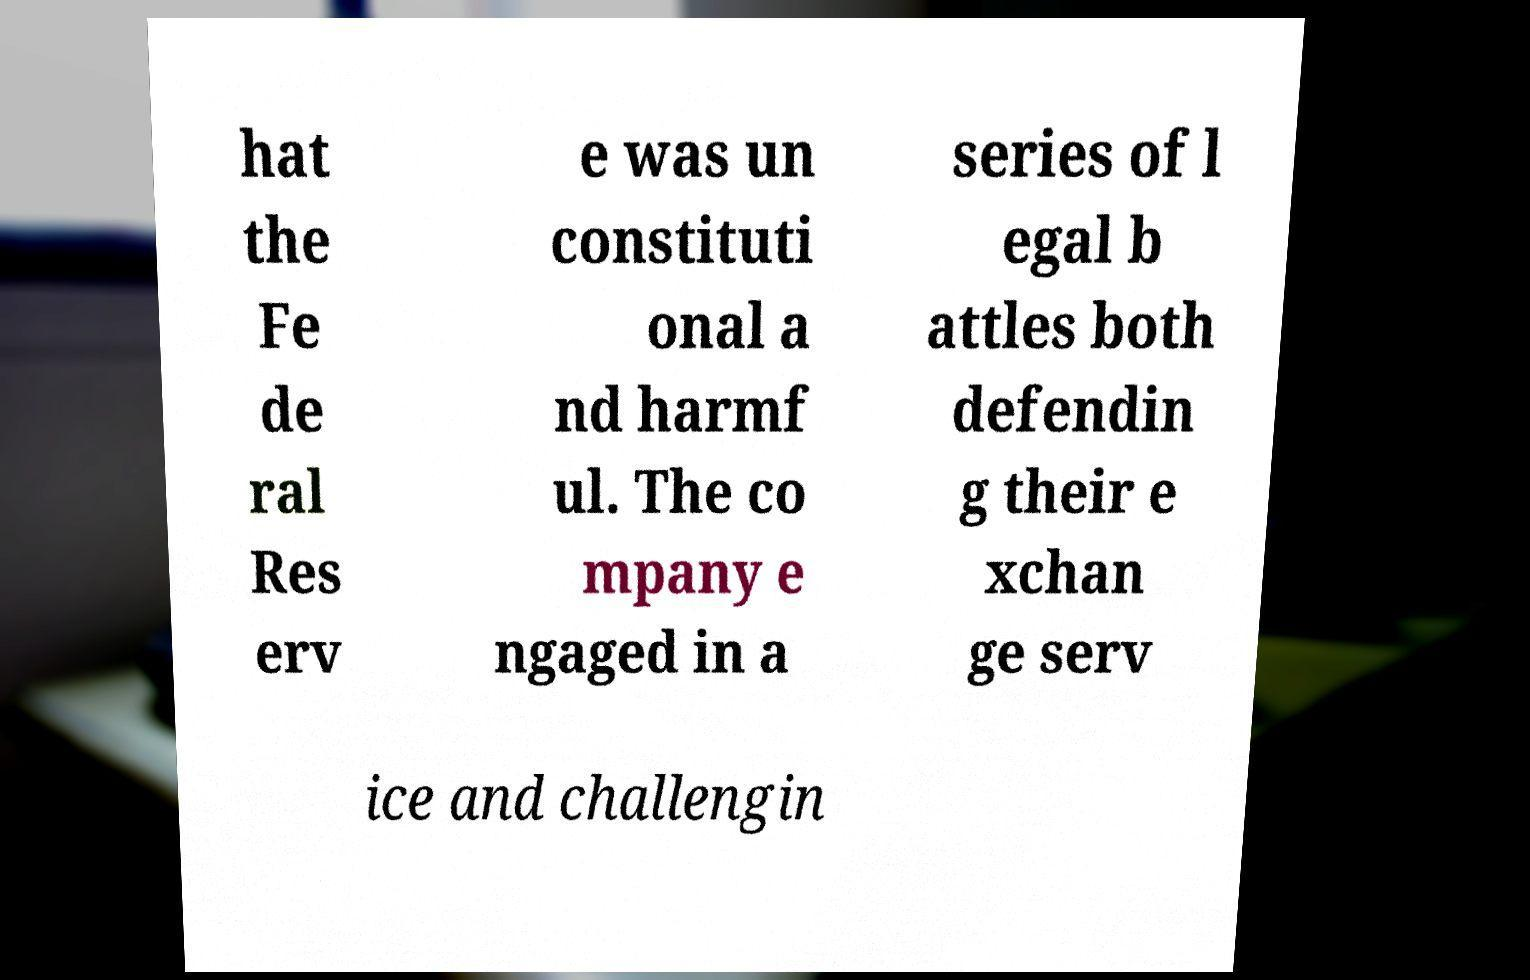Can you read and provide the text displayed in the image?This photo seems to have some interesting text. Can you extract and type it out for me? hat the Fe de ral Res erv e was un constituti onal a nd harmf ul. The co mpany e ngaged in a series of l egal b attles both defendin g their e xchan ge serv ice and challengin 